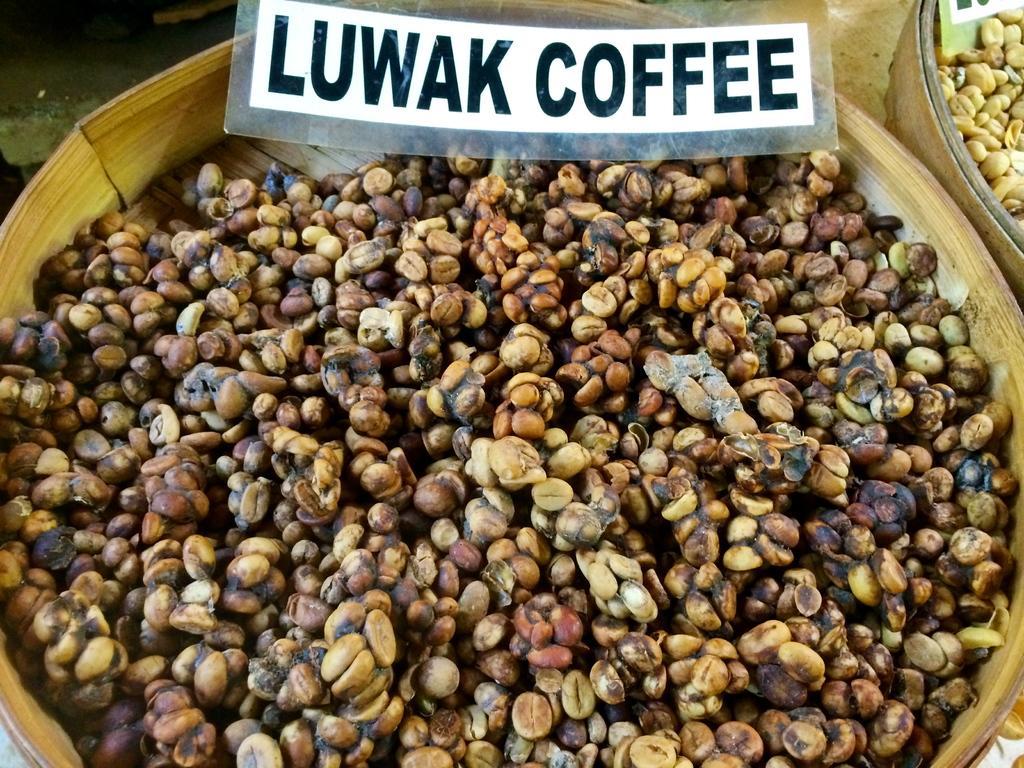Can you describe this image briefly? In this image I can see two baskets and in this baskets I can see beans. On the top of this image I can see few boards and on these words I can see something is written. 